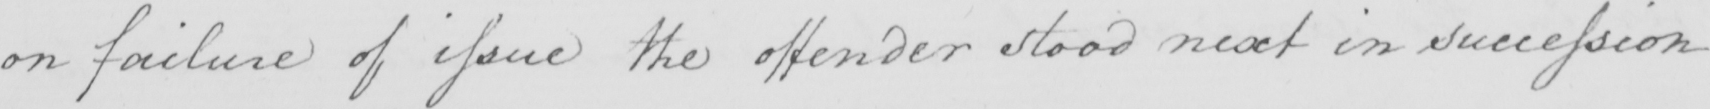Can you tell me what this handwritten text says? on failure of issue the offender stood next in succession 